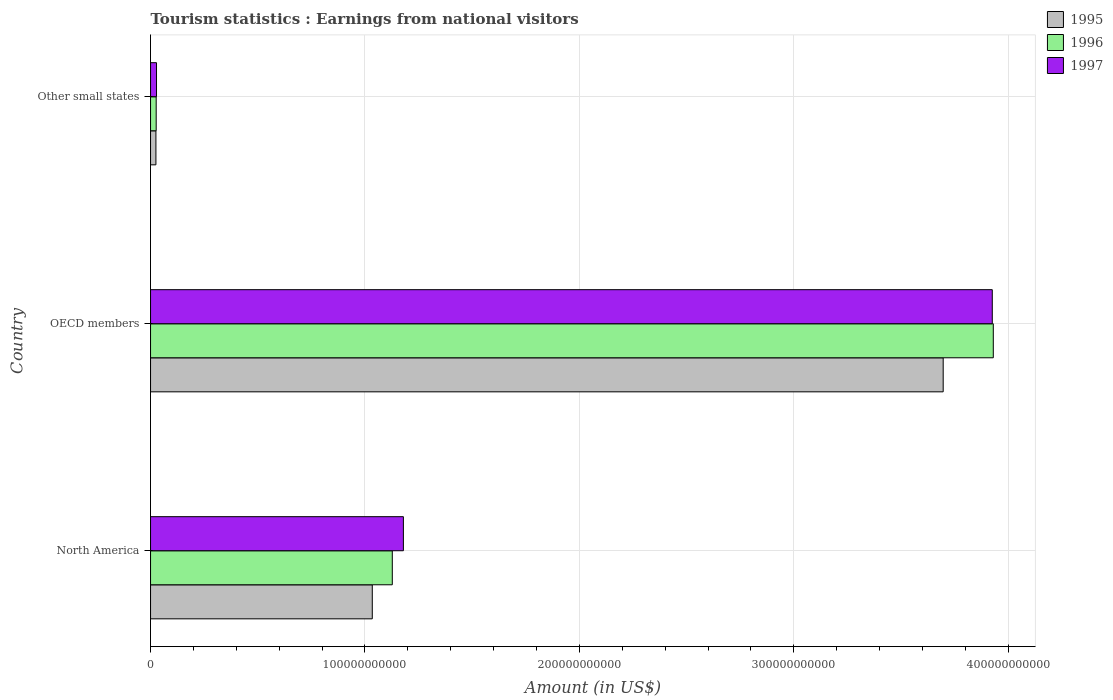Are the number of bars per tick equal to the number of legend labels?
Offer a very short reply. Yes. What is the label of the 2nd group of bars from the top?
Provide a short and direct response. OECD members. In how many cases, is the number of bars for a given country not equal to the number of legend labels?
Give a very brief answer. 0. What is the earnings from national visitors in 1997 in Other small states?
Give a very brief answer. 2.79e+09. Across all countries, what is the maximum earnings from national visitors in 1996?
Your response must be concise. 3.93e+11. Across all countries, what is the minimum earnings from national visitors in 1995?
Your answer should be very brief. 2.51e+09. In which country was the earnings from national visitors in 1995 maximum?
Make the answer very short. OECD members. In which country was the earnings from national visitors in 1996 minimum?
Your response must be concise. Other small states. What is the total earnings from national visitors in 1997 in the graph?
Your response must be concise. 5.13e+11. What is the difference between the earnings from national visitors in 1995 in OECD members and that in Other small states?
Make the answer very short. 3.67e+11. What is the difference between the earnings from national visitors in 1997 in Other small states and the earnings from national visitors in 1995 in OECD members?
Give a very brief answer. -3.67e+11. What is the average earnings from national visitors in 1996 per country?
Ensure brevity in your answer.  1.69e+11. What is the difference between the earnings from national visitors in 1996 and earnings from national visitors in 1995 in OECD members?
Offer a very short reply. 2.34e+1. In how many countries, is the earnings from national visitors in 1995 greater than 40000000000 US$?
Make the answer very short. 2. What is the ratio of the earnings from national visitors in 1995 in North America to that in OECD members?
Your answer should be very brief. 0.28. Is the earnings from national visitors in 1996 in OECD members less than that in Other small states?
Give a very brief answer. No. Is the difference between the earnings from national visitors in 1996 in OECD members and Other small states greater than the difference between the earnings from national visitors in 1995 in OECD members and Other small states?
Your response must be concise. Yes. What is the difference between the highest and the second highest earnings from national visitors in 1995?
Give a very brief answer. 2.66e+11. What is the difference between the highest and the lowest earnings from national visitors in 1997?
Provide a succinct answer. 3.90e+11. In how many countries, is the earnings from national visitors in 1996 greater than the average earnings from national visitors in 1996 taken over all countries?
Offer a terse response. 1. Is it the case that in every country, the sum of the earnings from national visitors in 1996 and earnings from national visitors in 1997 is greater than the earnings from national visitors in 1995?
Offer a very short reply. Yes. How many bars are there?
Keep it short and to the point. 9. Are all the bars in the graph horizontal?
Make the answer very short. Yes. How many countries are there in the graph?
Provide a succinct answer. 3. What is the difference between two consecutive major ticks on the X-axis?
Give a very brief answer. 1.00e+11. Where does the legend appear in the graph?
Offer a very short reply. Top right. How are the legend labels stacked?
Your response must be concise. Vertical. What is the title of the graph?
Your response must be concise. Tourism statistics : Earnings from national visitors. Does "2002" appear as one of the legend labels in the graph?
Your answer should be very brief. No. What is the label or title of the Y-axis?
Give a very brief answer. Country. What is the Amount (in US$) in 1995 in North America?
Keep it short and to the point. 1.03e+11. What is the Amount (in US$) in 1996 in North America?
Give a very brief answer. 1.13e+11. What is the Amount (in US$) of 1997 in North America?
Your answer should be compact. 1.18e+11. What is the Amount (in US$) in 1995 in OECD members?
Your answer should be compact. 3.70e+11. What is the Amount (in US$) of 1996 in OECD members?
Your response must be concise. 3.93e+11. What is the Amount (in US$) in 1997 in OECD members?
Provide a short and direct response. 3.93e+11. What is the Amount (in US$) in 1995 in Other small states?
Give a very brief answer. 2.51e+09. What is the Amount (in US$) in 1996 in Other small states?
Keep it short and to the point. 2.63e+09. What is the Amount (in US$) of 1997 in Other small states?
Your answer should be very brief. 2.79e+09. Across all countries, what is the maximum Amount (in US$) in 1995?
Your answer should be compact. 3.70e+11. Across all countries, what is the maximum Amount (in US$) of 1996?
Your answer should be compact. 3.93e+11. Across all countries, what is the maximum Amount (in US$) of 1997?
Make the answer very short. 3.93e+11. Across all countries, what is the minimum Amount (in US$) of 1995?
Your answer should be very brief. 2.51e+09. Across all countries, what is the minimum Amount (in US$) of 1996?
Offer a terse response. 2.63e+09. Across all countries, what is the minimum Amount (in US$) in 1997?
Provide a short and direct response. 2.79e+09. What is the total Amount (in US$) of 1995 in the graph?
Offer a very short reply. 4.76e+11. What is the total Amount (in US$) in 1996 in the graph?
Keep it short and to the point. 5.08e+11. What is the total Amount (in US$) of 1997 in the graph?
Provide a short and direct response. 5.13e+11. What is the difference between the Amount (in US$) of 1995 in North America and that in OECD members?
Your answer should be compact. -2.66e+11. What is the difference between the Amount (in US$) in 1996 in North America and that in OECD members?
Your answer should be compact. -2.80e+11. What is the difference between the Amount (in US$) in 1997 in North America and that in OECD members?
Your response must be concise. -2.75e+11. What is the difference between the Amount (in US$) of 1995 in North America and that in Other small states?
Your response must be concise. 1.01e+11. What is the difference between the Amount (in US$) of 1996 in North America and that in Other small states?
Give a very brief answer. 1.10e+11. What is the difference between the Amount (in US$) in 1997 in North America and that in Other small states?
Ensure brevity in your answer.  1.15e+11. What is the difference between the Amount (in US$) in 1995 in OECD members and that in Other small states?
Provide a short and direct response. 3.67e+11. What is the difference between the Amount (in US$) in 1996 in OECD members and that in Other small states?
Ensure brevity in your answer.  3.90e+11. What is the difference between the Amount (in US$) of 1997 in OECD members and that in Other small states?
Your answer should be very brief. 3.90e+11. What is the difference between the Amount (in US$) of 1995 in North America and the Amount (in US$) of 1996 in OECD members?
Provide a short and direct response. -2.90e+11. What is the difference between the Amount (in US$) of 1995 in North America and the Amount (in US$) of 1997 in OECD members?
Ensure brevity in your answer.  -2.89e+11. What is the difference between the Amount (in US$) of 1996 in North America and the Amount (in US$) of 1997 in OECD members?
Offer a terse response. -2.80e+11. What is the difference between the Amount (in US$) in 1995 in North America and the Amount (in US$) in 1996 in Other small states?
Keep it short and to the point. 1.01e+11. What is the difference between the Amount (in US$) in 1995 in North America and the Amount (in US$) in 1997 in Other small states?
Offer a very short reply. 1.01e+11. What is the difference between the Amount (in US$) in 1996 in North America and the Amount (in US$) in 1997 in Other small states?
Provide a short and direct response. 1.10e+11. What is the difference between the Amount (in US$) in 1995 in OECD members and the Amount (in US$) in 1996 in Other small states?
Your answer should be compact. 3.67e+11. What is the difference between the Amount (in US$) in 1995 in OECD members and the Amount (in US$) in 1997 in Other small states?
Make the answer very short. 3.67e+11. What is the difference between the Amount (in US$) in 1996 in OECD members and the Amount (in US$) in 1997 in Other small states?
Give a very brief answer. 3.90e+11. What is the average Amount (in US$) of 1995 per country?
Your answer should be very brief. 1.59e+11. What is the average Amount (in US$) in 1996 per country?
Ensure brevity in your answer.  1.69e+11. What is the average Amount (in US$) of 1997 per country?
Ensure brevity in your answer.  1.71e+11. What is the difference between the Amount (in US$) of 1995 and Amount (in US$) of 1996 in North America?
Provide a short and direct response. -9.33e+09. What is the difference between the Amount (in US$) of 1995 and Amount (in US$) of 1997 in North America?
Keep it short and to the point. -1.45e+1. What is the difference between the Amount (in US$) of 1996 and Amount (in US$) of 1997 in North America?
Give a very brief answer. -5.17e+09. What is the difference between the Amount (in US$) of 1995 and Amount (in US$) of 1996 in OECD members?
Provide a succinct answer. -2.34e+1. What is the difference between the Amount (in US$) of 1995 and Amount (in US$) of 1997 in OECD members?
Your response must be concise. -2.29e+1. What is the difference between the Amount (in US$) in 1996 and Amount (in US$) in 1997 in OECD members?
Your answer should be very brief. 4.73e+08. What is the difference between the Amount (in US$) in 1995 and Amount (in US$) in 1996 in Other small states?
Offer a very short reply. -1.23e+08. What is the difference between the Amount (in US$) of 1995 and Amount (in US$) of 1997 in Other small states?
Ensure brevity in your answer.  -2.78e+08. What is the difference between the Amount (in US$) of 1996 and Amount (in US$) of 1997 in Other small states?
Ensure brevity in your answer.  -1.55e+08. What is the ratio of the Amount (in US$) in 1995 in North America to that in OECD members?
Keep it short and to the point. 0.28. What is the ratio of the Amount (in US$) in 1996 in North America to that in OECD members?
Your response must be concise. 0.29. What is the ratio of the Amount (in US$) in 1997 in North America to that in OECD members?
Make the answer very short. 0.3. What is the ratio of the Amount (in US$) of 1995 in North America to that in Other small states?
Keep it short and to the point. 41.19. What is the ratio of the Amount (in US$) in 1996 in North America to that in Other small states?
Keep it short and to the point. 42.81. What is the ratio of the Amount (in US$) of 1997 in North America to that in Other small states?
Provide a succinct answer. 42.28. What is the ratio of the Amount (in US$) of 1995 in OECD members to that in Other small states?
Your response must be concise. 147.25. What is the ratio of the Amount (in US$) in 1996 in OECD members to that in Other small states?
Your response must be concise. 149.24. What is the ratio of the Amount (in US$) in 1997 in OECD members to that in Other small states?
Your answer should be compact. 140.76. What is the difference between the highest and the second highest Amount (in US$) of 1995?
Make the answer very short. 2.66e+11. What is the difference between the highest and the second highest Amount (in US$) of 1996?
Your response must be concise. 2.80e+11. What is the difference between the highest and the second highest Amount (in US$) in 1997?
Keep it short and to the point. 2.75e+11. What is the difference between the highest and the lowest Amount (in US$) in 1995?
Your response must be concise. 3.67e+11. What is the difference between the highest and the lowest Amount (in US$) of 1996?
Keep it short and to the point. 3.90e+11. What is the difference between the highest and the lowest Amount (in US$) of 1997?
Your response must be concise. 3.90e+11. 